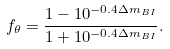<formula> <loc_0><loc_0><loc_500><loc_500>f _ { \theta } = \frac { 1 - 1 0 ^ { - 0 . 4 \Delta m _ { B I } } } { 1 + 1 0 ^ { - 0 . 4 \Delta m _ { B I } } } .</formula> 